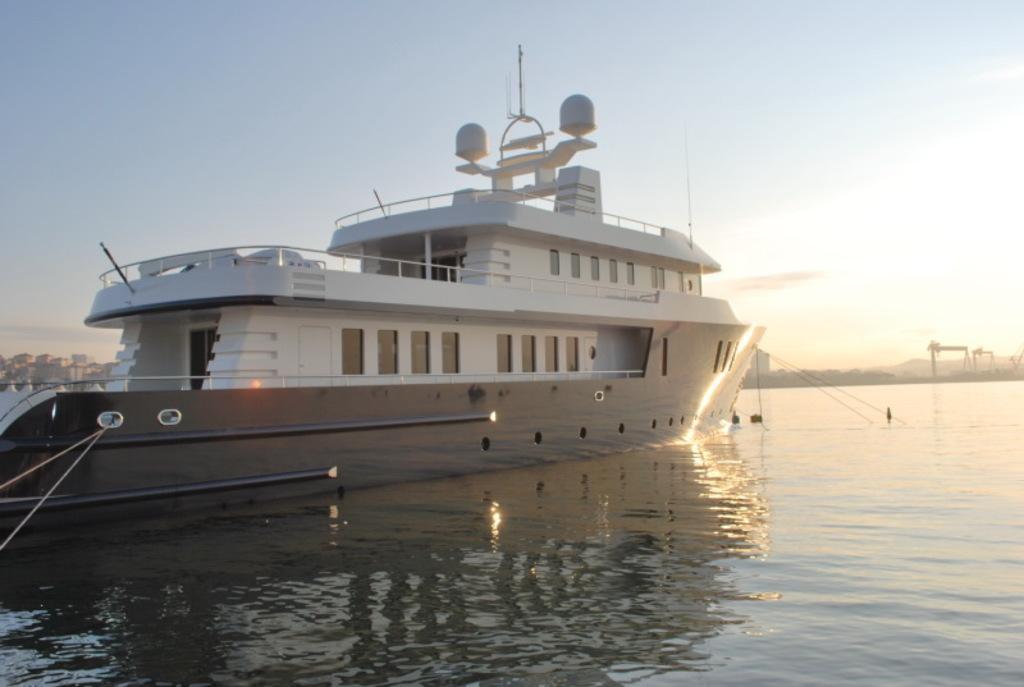How would you summarize this image in a sentence or two? This picture shows a ship in the water and we see a blue cloudy sky and few buildings. 